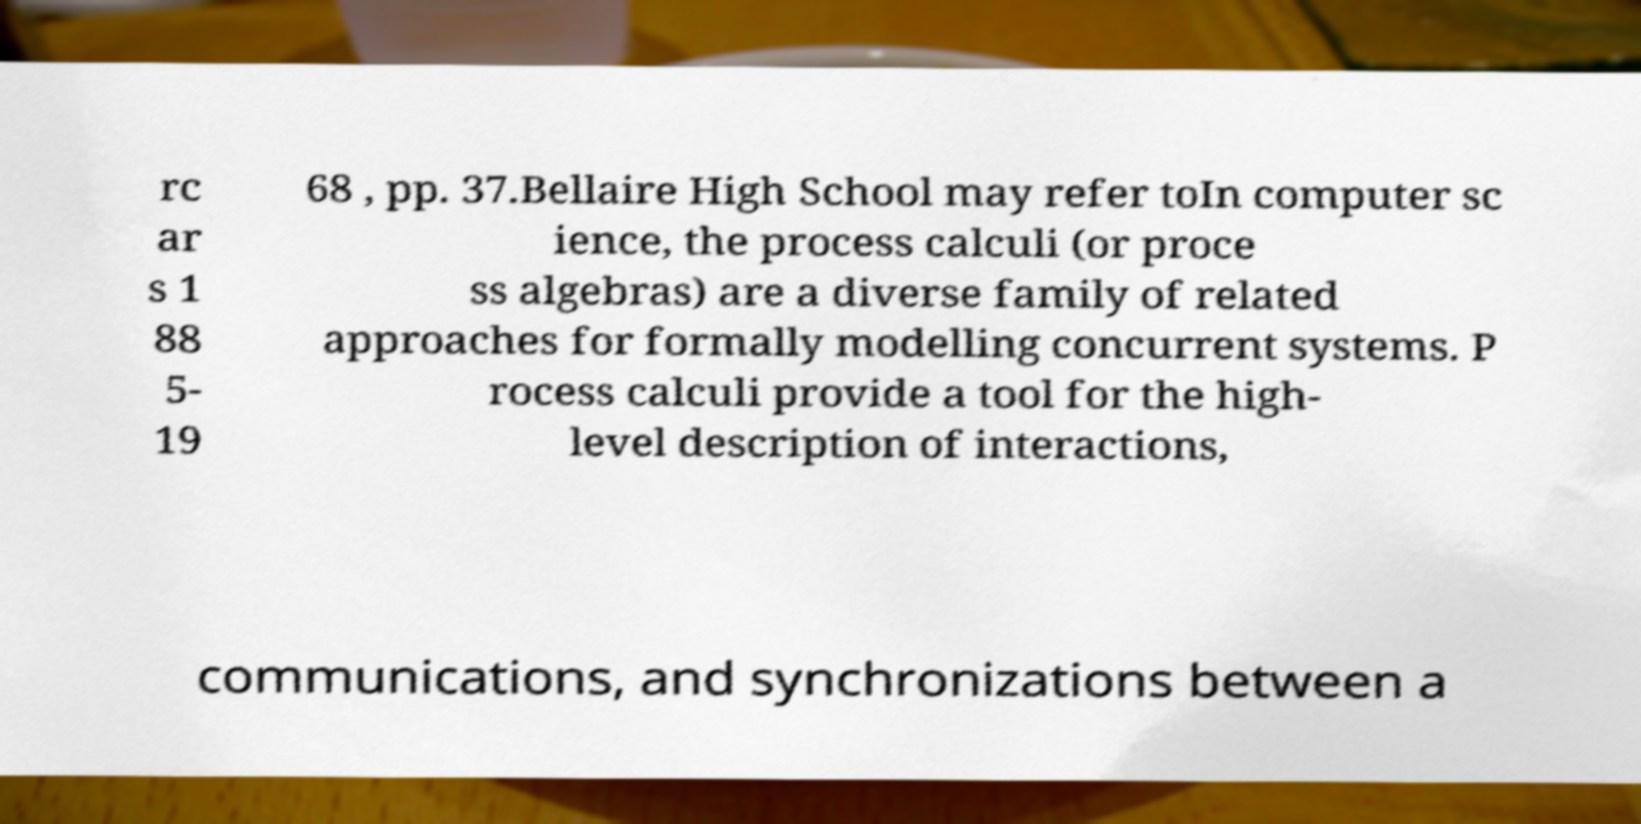Please identify and transcribe the text found in this image. rc ar s 1 88 5- 19 68 , pp. 37.Bellaire High School may refer toIn computer sc ience, the process calculi (or proce ss algebras) are a diverse family of related approaches for formally modelling concurrent systems. P rocess calculi provide a tool for the high- level description of interactions, communications, and synchronizations between a 